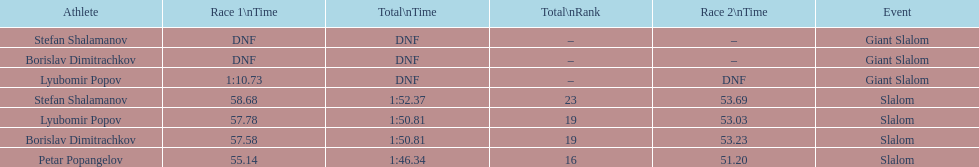Help me parse the entirety of this table. {'header': ['Athlete', 'Race 1\\nTime', 'Total\\nTime', 'Total\\nRank', 'Race 2\\nTime', 'Event'], 'rows': [['Stefan Shalamanov', 'DNF', 'DNF', '–', '–', 'Giant Slalom'], ['Borislav Dimitrachkov', 'DNF', 'DNF', '–', '–', 'Giant Slalom'], ['Lyubomir Popov', '1:10.73', 'DNF', '–', 'DNF', 'Giant Slalom'], ['Stefan Shalamanov', '58.68', '1:52.37', '23', '53.69', 'Slalom'], ['Lyubomir Popov', '57.78', '1:50.81', '19', '53.03', 'Slalom'], ['Borislav Dimitrachkov', '57.58', '1:50.81', '19', '53.23', 'Slalom'], ['Petar Popangelov', '55.14', '1:46.34', '16', '51.20', 'Slalom']]} What is the number of athletes to finish race one in the giant slalom? 1. 